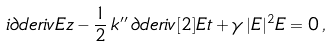Convert formula to latex. <formula><loc_0><loc_0><loc_500><loc_500>i \partial d e r i v E z - \frac { 1 } { 2 } \, k ^ { \prime \prime } \, \partial d e r i v [ 2 ] E t + \gamma \, | E | ^ { 2 } E = 0 \, ,</formula> 